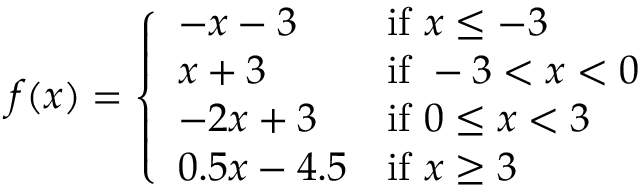<formula> <loc_0><loc_0><loc_500><loc_500>f ( x ) = { \left \{ \begin{array} { l l } { - x - 3 } & { { i f } x \leq - 3 } \\ { x + 3 } & { { i f } - 3 < x < 0 } \\ { - 2 x + 3 } & { { i f } 0 \leq x < 3 } \\ { 0 . 5 x - 4 . 5 } & { { i f } x \geq 3 } \end{array} }</formula> 